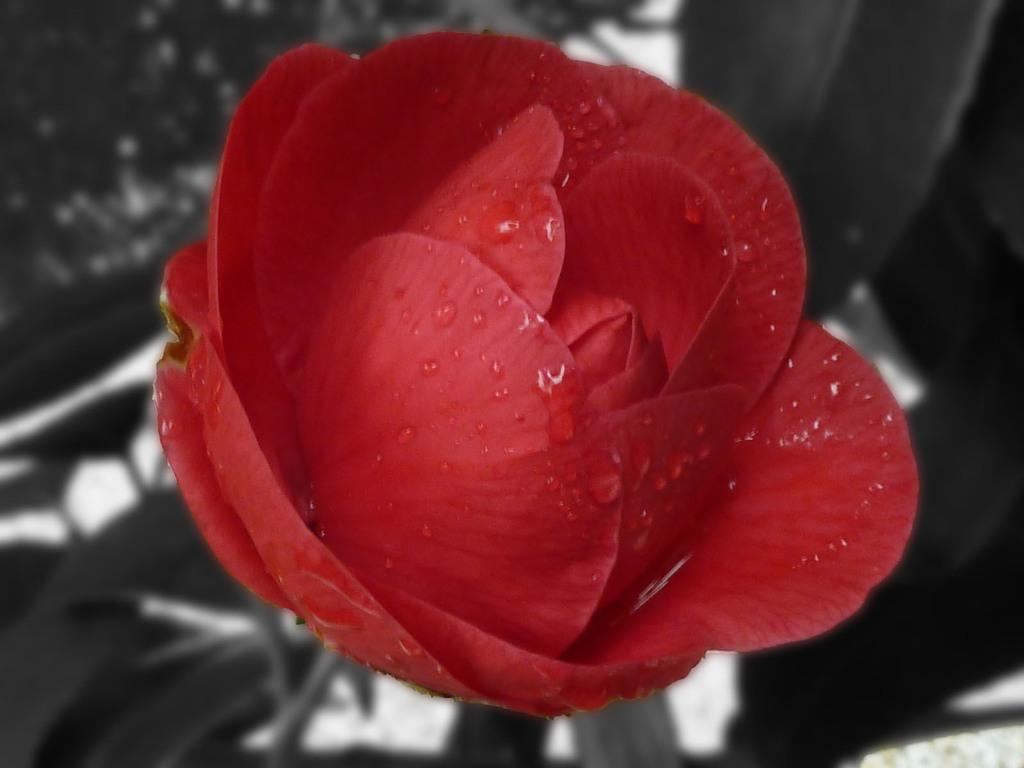What is the main subject of the picture? There is a flower in the picture. What can be observed on the flower? There are water droplets on the flower. What else can be seen in the background of the picture? There are plants visible in the background of the picture. Can you tell me how many notes are attached to the cushion in the image? There is no cushion or note present in the image; it only features a flower with water droplets and plants in the background. 